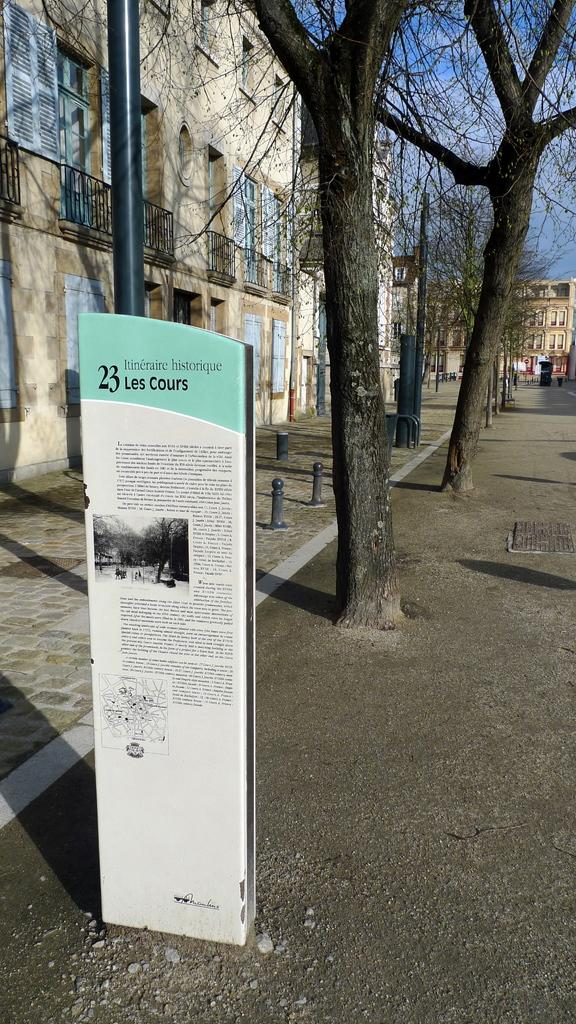What type of structures can be seen in the image? There are buildings in the image. What is located in front of the buildings? There are trees in front of the buildings. What objects can be seen on the pavement? There are rods on the pavement. What is hanging over the road in the image? There is a banner on the road. What type of weather can be seen in the image? The provided facts do not mention any weather conditions, so it cannot be determined from the image. 